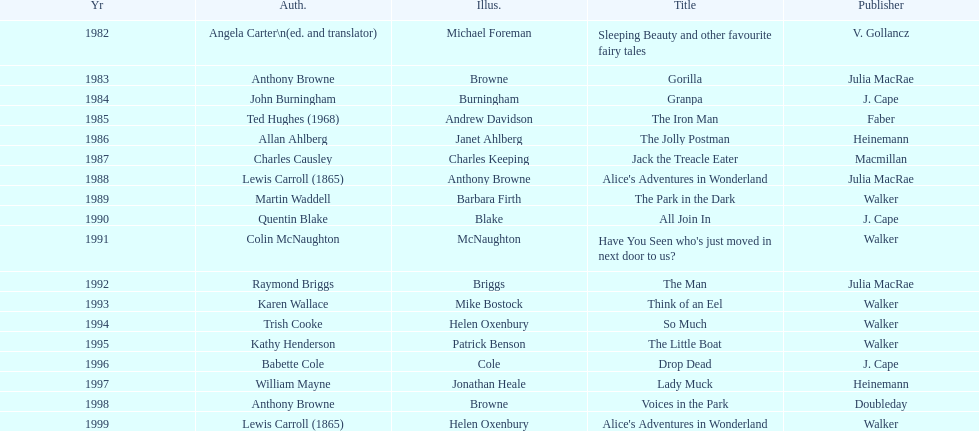How many total titles were published by walker? 5. 